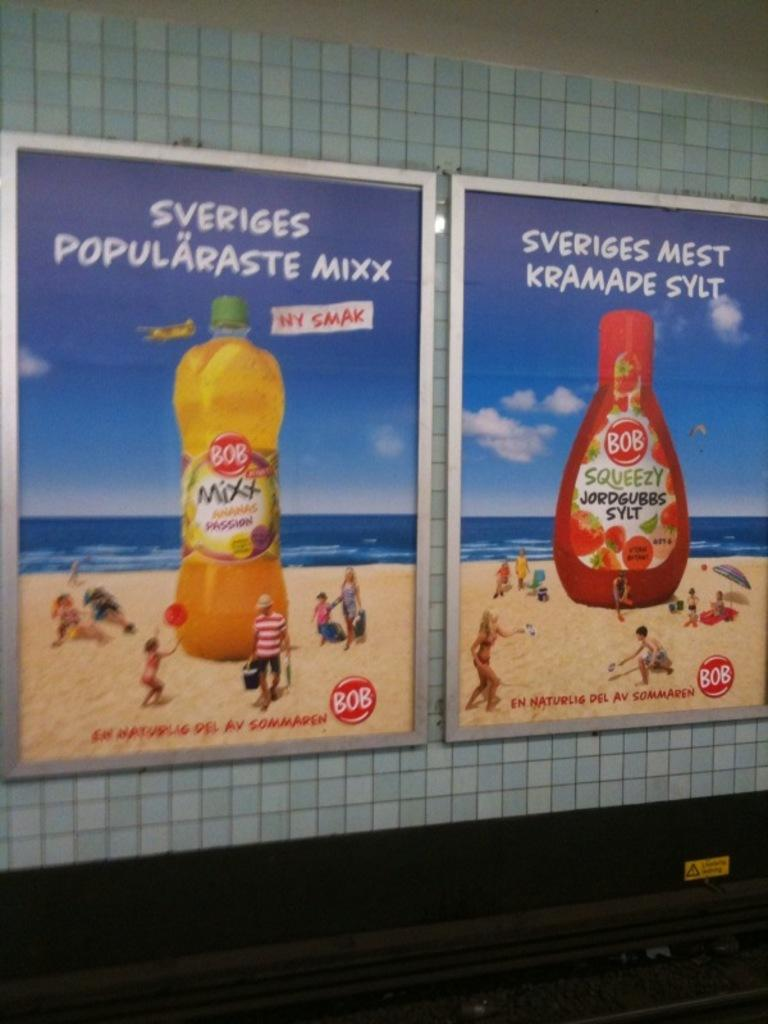Provide a one-sentence caption for the provided image. Two ads for Bob products are side by side on a wall. 